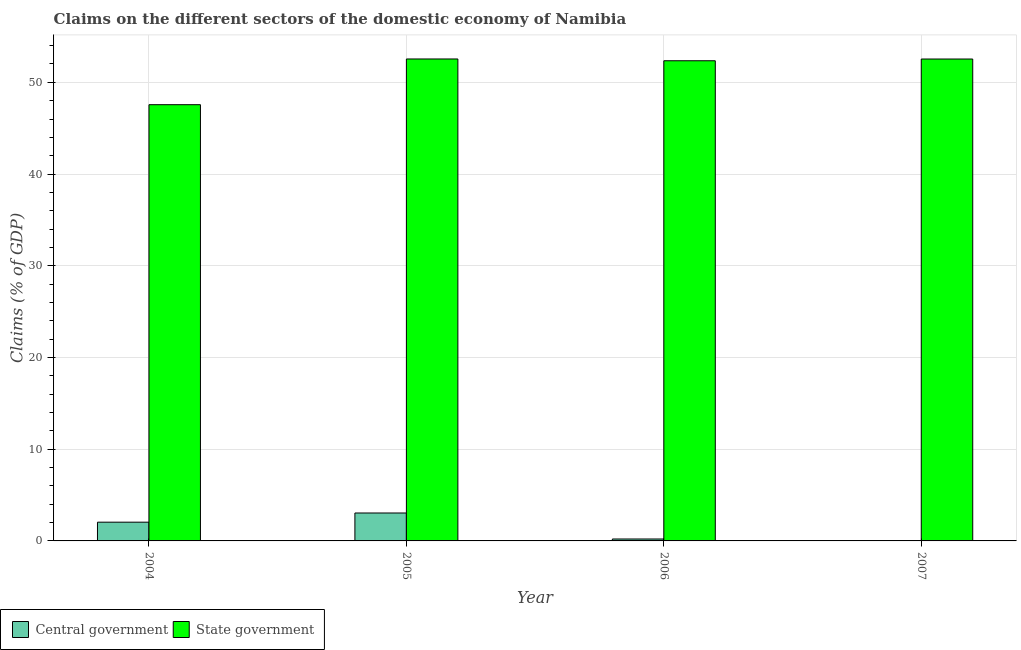How many different coloured bars are there?
Offer a terse response. 2. What is the label of the 2nd group of bars from the left?
Ensure brevity in your answer.  2005. What is the claims on central government in 2004?
Give a very brief answer. 2.04. Across all years, what is the maximum claims on central government?
Your answer should be very brief. 3.04. Across all years, what is the minimum claims on state government?
Keep it short and to the point. 47.56. What is the total claims on state government in the graph?
Provide a short and direct response. 205. What is the difference between the claims on central government in 2004 and that in 2006?
Offer a very short reply. 1.83. What is the difference between the claims on central government in 2006 and the claims on state government in 2004?
Your answer should be compact. -1.83. What is the average claims on central government per year?
Offer a terse response. 1.32. In how many years, is the claims on state government greater than 48 %?
Make the answer very short. 3. What is the ratio of the claims on state government in 2004 to that in 2005?
Provide a short and direct response. 0.91. Is the difference between the claims on central government in 2004 and 2006 greater than the difference between the claims on state government in 2004 and 2006?
Provide a succinct answer. No. What is the difference between the highest and the second highest claims on state government?
Ensure brevity in your answer.  0.01. What is the difference between the highest and the lowest claims on state government?
Ensure brevity in your answer.  4.99. Is the sum of the claims on state government in 2005 and 2007 greater than the maximum claims on central government across all years?
Keep it short and to the point. Yes. Are all the bars in the graph horizontal?
Offer a very short reply. No. How many years are there in the graph?
Make the answer very short. 4. Does the graph contain any zero values?
Provide a succinct answer. Yes. Does the graph contain grids?
Your response must be concise. Yes. Where does the legend appear in the graph?
Make the answer very short. Bottom left. How many legend labels are there?
Ensure brevity in your answer.  2. How are the legend labels stacked?
Ensure brevity in your answer.  Horizontal. What is the title of the graph?
Make the answer very short. Claims on the different sectors of the domestic economy of Namibia. Does "Adolescent fertility rate" appear as one of the legend labels in the graph?
Your answer should be very brief. No. What is the label or title of the Y-axis?
Provide a succinct answer. Claims (% of GDP). What is the Claims (% of GDP) of Central government in 2004?
Give a very brief answer. 2.04. What is the Claims (% of GDP) of State government in 2004?
Keep it short and to the point. 47.56. What is the Claims (% of GDP) of Central government in 2005?
Keep it short and to the point. 3.04. What is the Claims (% of GDP) of State government in 2005?
Provide a short and direct response. 52.55. What is the Claims (% of GDP) in Central government in 2006?
Your answer should be very brief. 0.21. What is the Claims (% of GDP) of State government in 2006?
Offer a terse response. 52.35. What is the Claims (% of GDP) in Central government in 2007?
Your response must be concise. 0. What is the Claims (% of GDP) in State government in 2007?
Offer a terse response. 52.54. Across all years, what is the maximum Claims (% of GDP) in Central government?
Make the answer very short. 3.04. Across all years, what is the maximum Claims (% of GDP) of State government?
Make the answer very short. 52.55. Across all years, what is the minimum Claims (% of GDP) in State government?
Your answer should be very brief. 47.56. What is the total Claims (% of GDP) in Central government in the graph?
Keep it short and to the point. 5.3. What is the total Claims (% of GDP) in State government in the graph?
Offer a terse response. 205. What is the difference between the Claims (% of GDP) in Central government in 2004 and that in 2005?
Make the answer very short. -1. What is the difference between the Claims (% of GDP) in State government in 2004 and that in 2005?
Provide a succinct answer. -4.99. What is the difference between the Claims (% of GDP) in Central government in 2004 and that in 2006?
Keep it short and to the point. 1.83. What is the difference between the Claims (% of GDP) of State government in 2004 and that in 2006?
Make the answer very short. -4.79. What is the difference between the Claims (% of GDP) of State government in 2004 and that in 2007?
Offer a very short reply. -4.98. What is the difference between the Claims (% of GDP) in Central government in 2005 and that in 2006?
Keep it short and to the point. 2.83. What is the difference between the Claims (% of GDP) of State government in 2005 and that in 2006?
Your answer should be compact. 0.2. What is the difference between the Claims (% of GDP) of State government in 2005 and that in 2007?
Keep it short and to the point. 0.01. What is the difference between the Claims (% of GDP) of State government in 2006 and that in 2007?
Your answer should be very brief. -0.19. What is the difference between the Claims (% of GDP) of Central government in 2004 and the Claims (% of GDP) of State government in 2005?
Provide a succinct answer. -50.5. What is the difference between the Claims (% of GDP) of Central government in 2004 and the Claims (% of GDP) of State government in 2006?
Your response must be concise. -50.31. What is the difference between the Claims (% of GDP) in Central government in 2004 and the Claims (% of GDP) in State government in 2007?
Make the answer very short. -50.5. What is the difference between the Claims (% of GDP) of Central government in 2005 and the Claims (% of GDP) of State government in 2006?
Your answer should be compact. -49.31. What is the difference between the Claims (% of GDP) in Central government in 2005 and the Claims (% of GDP) in State government in 2007?
Your answer should be compact. -49.5. What is the difference between the Claims (% of GDP) in Central government in 2006 and the Claims (% of GDP) in State government in 2007?
Keep it short and to the point. -52.33. What is the average Claims (% of GDP) in Central government per year?
Keep it short and to the point. 1.32. What is the average Claims (% of GDP) of State government per year?
Ensure brevity in your answer.  51.25. In the year 2004, what is the difference between the Claims (% of GDP) of Central government and Claims (% of GDP) of State government?
Give a very brief answer. -45.52. In the year 2005, what is the difference between the Claims (% of GDP) in Central government and Claims (% of GDP) in State government?
Your response must be concise. -49.5. In the year 2006, what is the difference between the Claims (% of GDP) of Central government and Claims (% of GDP) of State government?
Your answer should be very brief. -52.14. What is the ratio of the Claims (% of GDP) in Central government in 2004 to that in 2005?
Offer a terse response. 0.67. What is the ratio of the Claims (% of GDP) in State government in 2004 to that in 2005?
Ensure brevity in your answer.  0.91. What is the ratio of the Claims (% of GDP) of Central government in 2004 to that in 2006?
Your response must be concise. 9.74. What is the ratio of the Claims (% of GDP) in State government in 2004 to that in 2006?
Keep it short and to the point. 0.91. What is the ratio of the Claims (% of GDP) of State government in 2004 to that in 2007?
Provide a succinct answer. 0.91. What is the ratio of the Claims (% of GDP) of Central government in 2005 to that in 2006?
Your answer should be compact. 14.51. What is the ratio of the Claims (% of GDP) of State government in 2005 to that in 2006?
Provide a short and direct response. 1. What is the ratio of the Claims (% of GDP) of State government in 2005 to that in 2007?
Provide a succinct answer. 1. What is the difference between the highest and the second highest Claims (% of GDP) in Central government?
Make the answer very short. 1. What is the difference between the highest and the second highest Claims (% of GDP) in State government?
Offer a very short reply. 0.01. What is the difference between the highest and the lowest Claims (% of GDP) of Central government?
Keep it short and to the point. 3.04. What is the difference between the highest and the lowest Claims (% of GDP) in State government?
Ensure brevity in your answer.  4.99. 